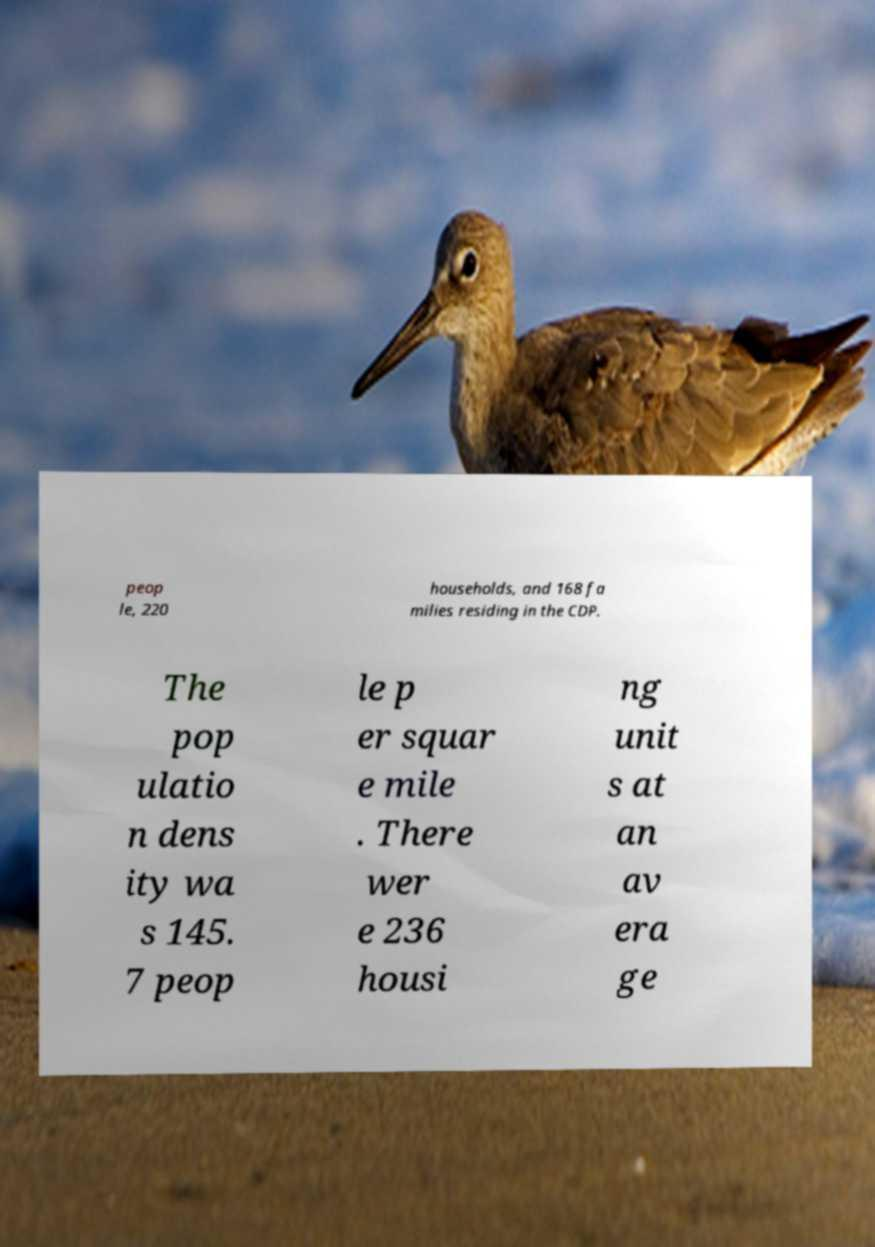Please identify and transcribe the text found in this image. peop le, 220 households, and 168 fa milies residing in the CDP. The pop ulatio n dens ity wa s 145. 7 peop le p er squar e mile . There wer e 236 housi ng unit s at an av era ge 